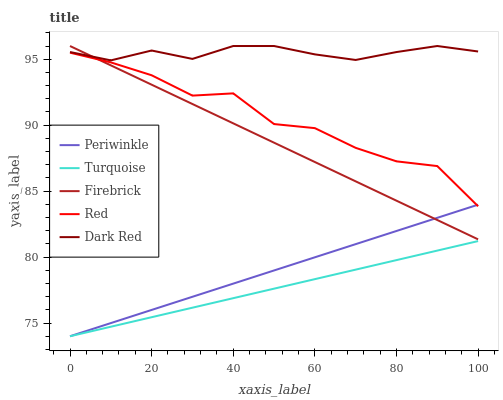Does Turquoise have the minimum area under the curve?
Answer yes or no. Yes. Does Dark Red have the maximum area under the curve?
Answer yes or no. Yes. Does Periwinkle have the minimum area under the curve?
Answer yes or no. No. Does Periwinkle have the maximum area under the curve?
Answer yes or no. No. Is Periwinkle the smoothest?
Answer yes or no. Yes. Is Red the roughest?
Answer yes or no. Yes. Is Turquoise the smoothest?
Answer yes or no. No. Is Turquoise the roughest?
Answer yes or no. No. Does Turquoise have the lowest value?
Answer yes or no. Yes. Does Firebrick have the lowest value?
Answer yes or no. No. Does Firebrick have the highest value?
Answer yes or no. Yes. Does Periwinkle have the highest value?
Answer yes or no. No. Is Periwinkle less than Dark Red?
Answer yes or no. Yes. Is Dark Red greater than Red?
Answer yes or no. Yes. Does Red intersect Firebrick?
Answer yes or no. Yes. Is Red less than Firebrick?
Answer yes or no. No. Is Red greater than Firebrick?
Answer yes or no. No. Does Periwinkle intersect Dark Red?
Answer yes or no. No. 